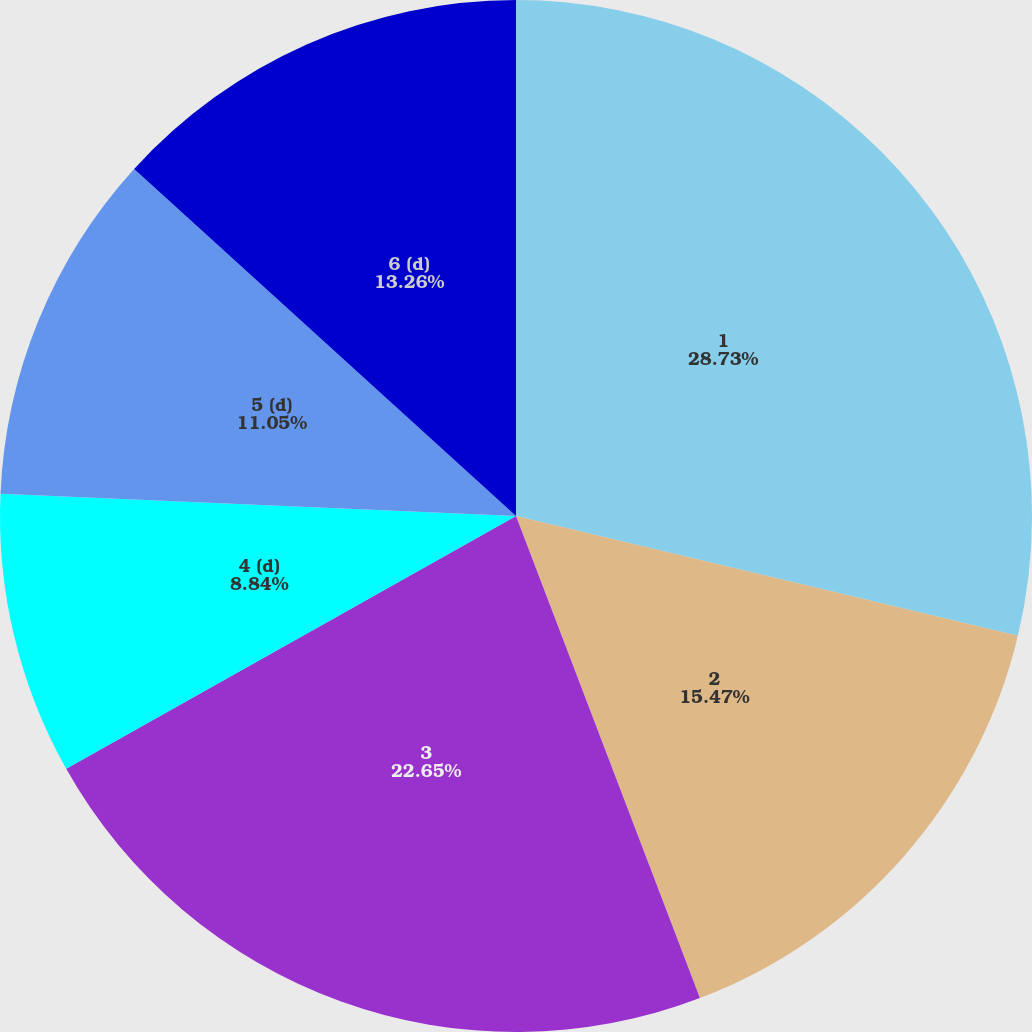<chart> <loc_0><loc_0><loc_500><loc_500><pie_chart><fcel>1<fcel>2<fcel>3<fcel>4 (d)<fcel>5 (d)<fcel>6 (d)<nl><fcel>28.73%<fcel>15.47%<fcel>22.65%<fcel>8.84%<fcel>11.05%<fcel>13.26%<nl></chart> 